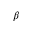Convert formula to latex. <formula><loc_0><loc_0><loc_500><loc_500>\beta</formula> 